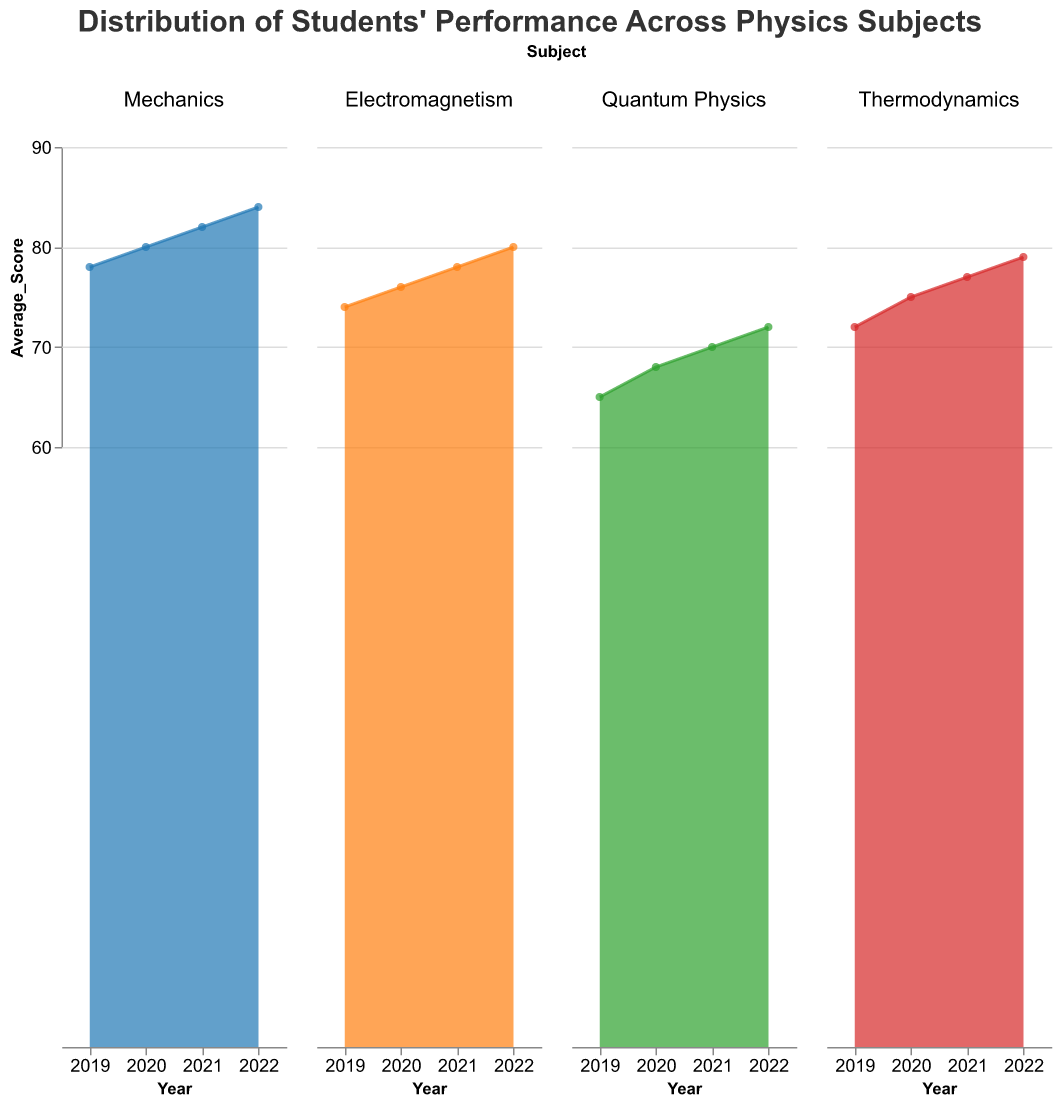What is the title of the figure? The title of the figure is displayed at the top of the chart and it's a descriptive text summarizing the chart's content.
Answer: Distribution of Students' Performance Across Physics Subjects Which subject had the highest average score in 2022? From the subplot, the line for "Mechanics" in 2022 is the highest compared to other subjects.
Answer: Mechanics In 2020, which subject had the lowest average score? By looking at the subplot for 2020, "Quantum Physics" has the lowest point on the y-axis.
Answer: Quantum Physics Across the academic years, which subject has shown the most consistent improvement in average scores? By observing all subplots, "Mechanics" shows a steady increase from 2019 to 2022.
Answer: Mechanics Calculate the average of the yearly average scores for Electromagnetism. The average scores for Electromagnetism over years are 74 (2019), 76 (2020), 78 (2021), and 80 (2022). The sum is 74 + 76 + 78 + 80 = 308. The average is 308 / 4 = 77.
Answer: 77 How has the percentage of female students in Quantum Physics changed from 2019 to 2022? In 2019, the female percentage is 42% and in 2022 it is 48%. The increase is 48% - 42% = 6%.
Answer: Increased by 6% Which year had the highest combined average score across all subjects? Add the average scores of all subjects for each year and compare. 2019: 78 + 74 + 65 + 72 = 289, 2020: 80 + 76 + 68 + 75 = 299, 2021: 82 + 78 + 70 + 77 = 307, 2022: 84 + 80 + 72 + 79 = 315. The highest total is in 2022.
Answer: 2022 What is the difference in average scores between Thermodynamics and Quantum Physics in 2021? For 2021, Thermodynamics has a score of 77 and Quantum Physics has 70. The difference is 77 - 70 = 7.
Answer: 7 Compare the gender distribution in Mechanics between 2019 and 2022. In 2019, the female percentage is 48% and male 52%. In 2022, female percentage is 53% and male 47%.
Answer: Female increased by 5%, Male decreased by 5% Which subject shows the greatest variability in scores over the years? By comparing the range (max-min) of average scores in each subject: Mechanics (84-78=6), Electromagnetism (80-74=6), Quantum Physics (72-65=7), Thermodynamics (79-72=7). Quantum Physics and Thermodynamics both have the greatest range of 7.
Answer: Quantum Physics and Thermodynamics 